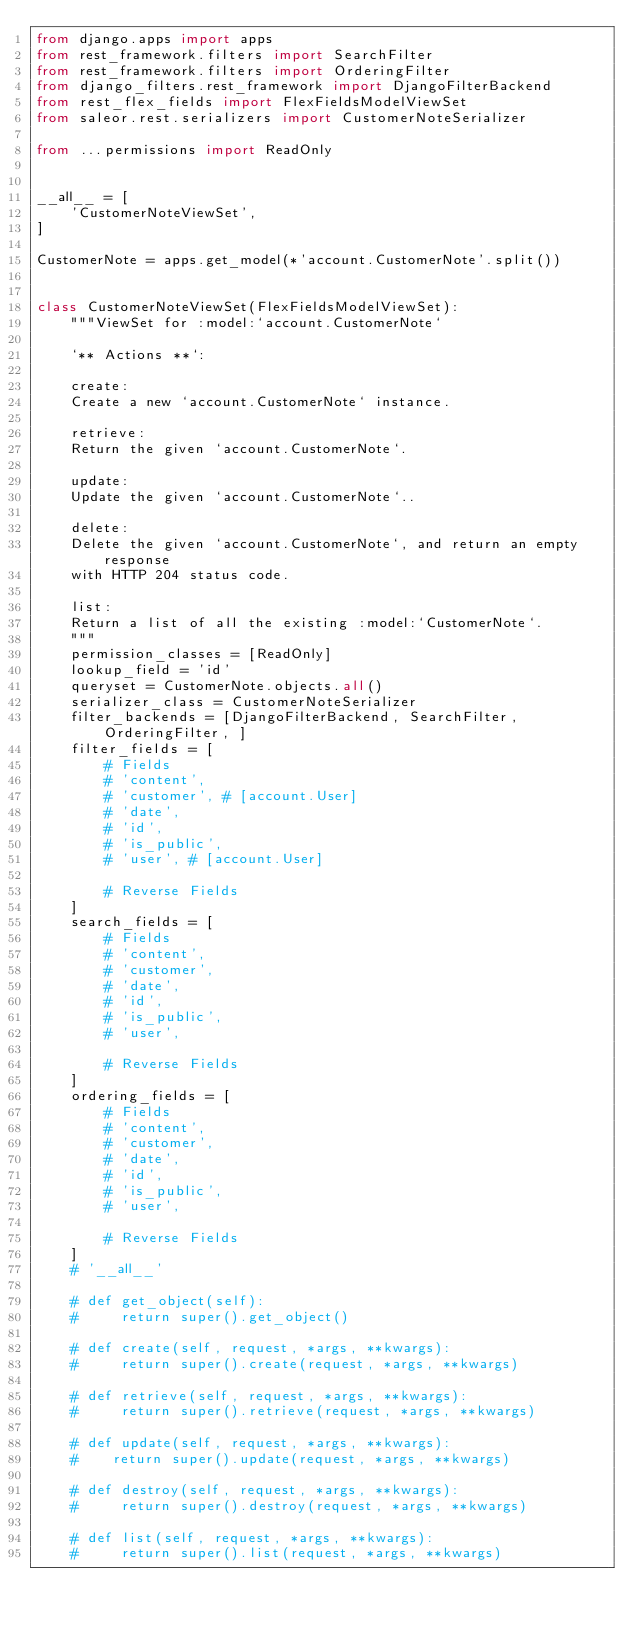<code> <loc_0><loc_0><loc_500><loc_500><_Python_>from django.apps import apps
from rest_framework.filters import SearchFilter
from rest_framework.filters import OrderingFilter
from django_filters.rest_framework import DjangoFilterBackend
from rest_flex_fields import FlexFieldsModelViewSet
from saleor.rest.serializers import CustomerNoteSerializer

from ...permissions import ReadOnly


__all__ = [
    'CustomerNoteViewSet',
]

CustomerNote = apps.get_model(*'account.CustomerNote'.split())


class CustomerNoteViewSet(FlexFieldsModelViewSet):
    """ViewSet for :model:`account.CustomerNote`

    `** Actions **`:

    create:
    Create a new `account.CustomerNote` instance.

    retrieve:
    Return the given `account.CustomerNote`.

    update:
    Update the given `account.CustomerNote`..

    delete:
    Delete the given `account.CustomerNote`, and return an empty response
    with HTTP 204 status code.

    list:
    Return a list of all the existing :model:`CustomerNote`.
    """
    permission_classes = [ReadOnly]
    lookup_field = 'id'
    queryset = CustomerNote.objects.all()
    serializer_class = CustomerNoteSerializer
    filter_backends = [DjangoFilterBackend, SearchFilter, OrderingFilter, ]
    filter_fields = [
        # Fields
        # 'content',
        # 'customer', # [account.User]
        # 'date',
        # 'id',
        # 'is_public',
        # 'user', # [account.User]

        # Reverse Fields
    ]
    search_fields = [
        # Fields
        # 'content',
        # 'customer',
        # 'date',
        # 'id',
        # 'is_public',
        # 'user',

        # Reverse Fields
    ]
    ordering_fields = [
        # Fields
        # 'content',
        # 'customer',
        # 'date',
        # 'id',
        # 'is_public',
        # 'user',

        # Reverse Fields
    ]
    # '__all__'

    # def get_object(self):
    #     return super().get_object()

    # def create(self, request, *args, **kwargs):
    #     return super().create(request, *args, **kwargs)

    # def retrieve(self, request, *args, **kwargs):
    #     return super().retrieve(request, *args, **kwargs)

    # def update(self, request, *args, **kwargs):
    #    return super().update(request, *args, **kwargs)

    # def destroy(self, request, *args, **kwargs):
    #     return super().destroy(request, *args, **kwargs)

    # def list(self, request, *args, **kwargs):
    #     return super().list(request, *args, **kwargs)
</code> 